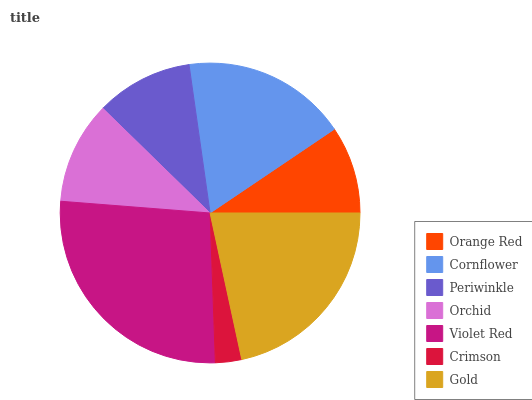Is Crimson the minimum?
Answer yes or no. Yes. Is Violet Red the maximum?
Answer yes or no. Yes. Is Cornflower the minimum?
Answer yes or no. No. Is Cornflower the maximum?
Answer yes or no. No. Is Cornflower greater than Orange Red?
Answer yes or no. Yes. Is Orange Red less than Cornflower?
Answer yes or no. Yes. Is Orange Red greater than Cornflower?
Answer yes or no. No. Is Cornflower less than Orange Red?
Answer yes or no. No. Is Orchid the high median?
Answer yes or no. Yes. Is Orchid the low median?
Answer yes or no. Yes. Is Orange Red the high median?
Answer yes or no. No. Is Cornflower the low median?
Answer yes or no. No. 